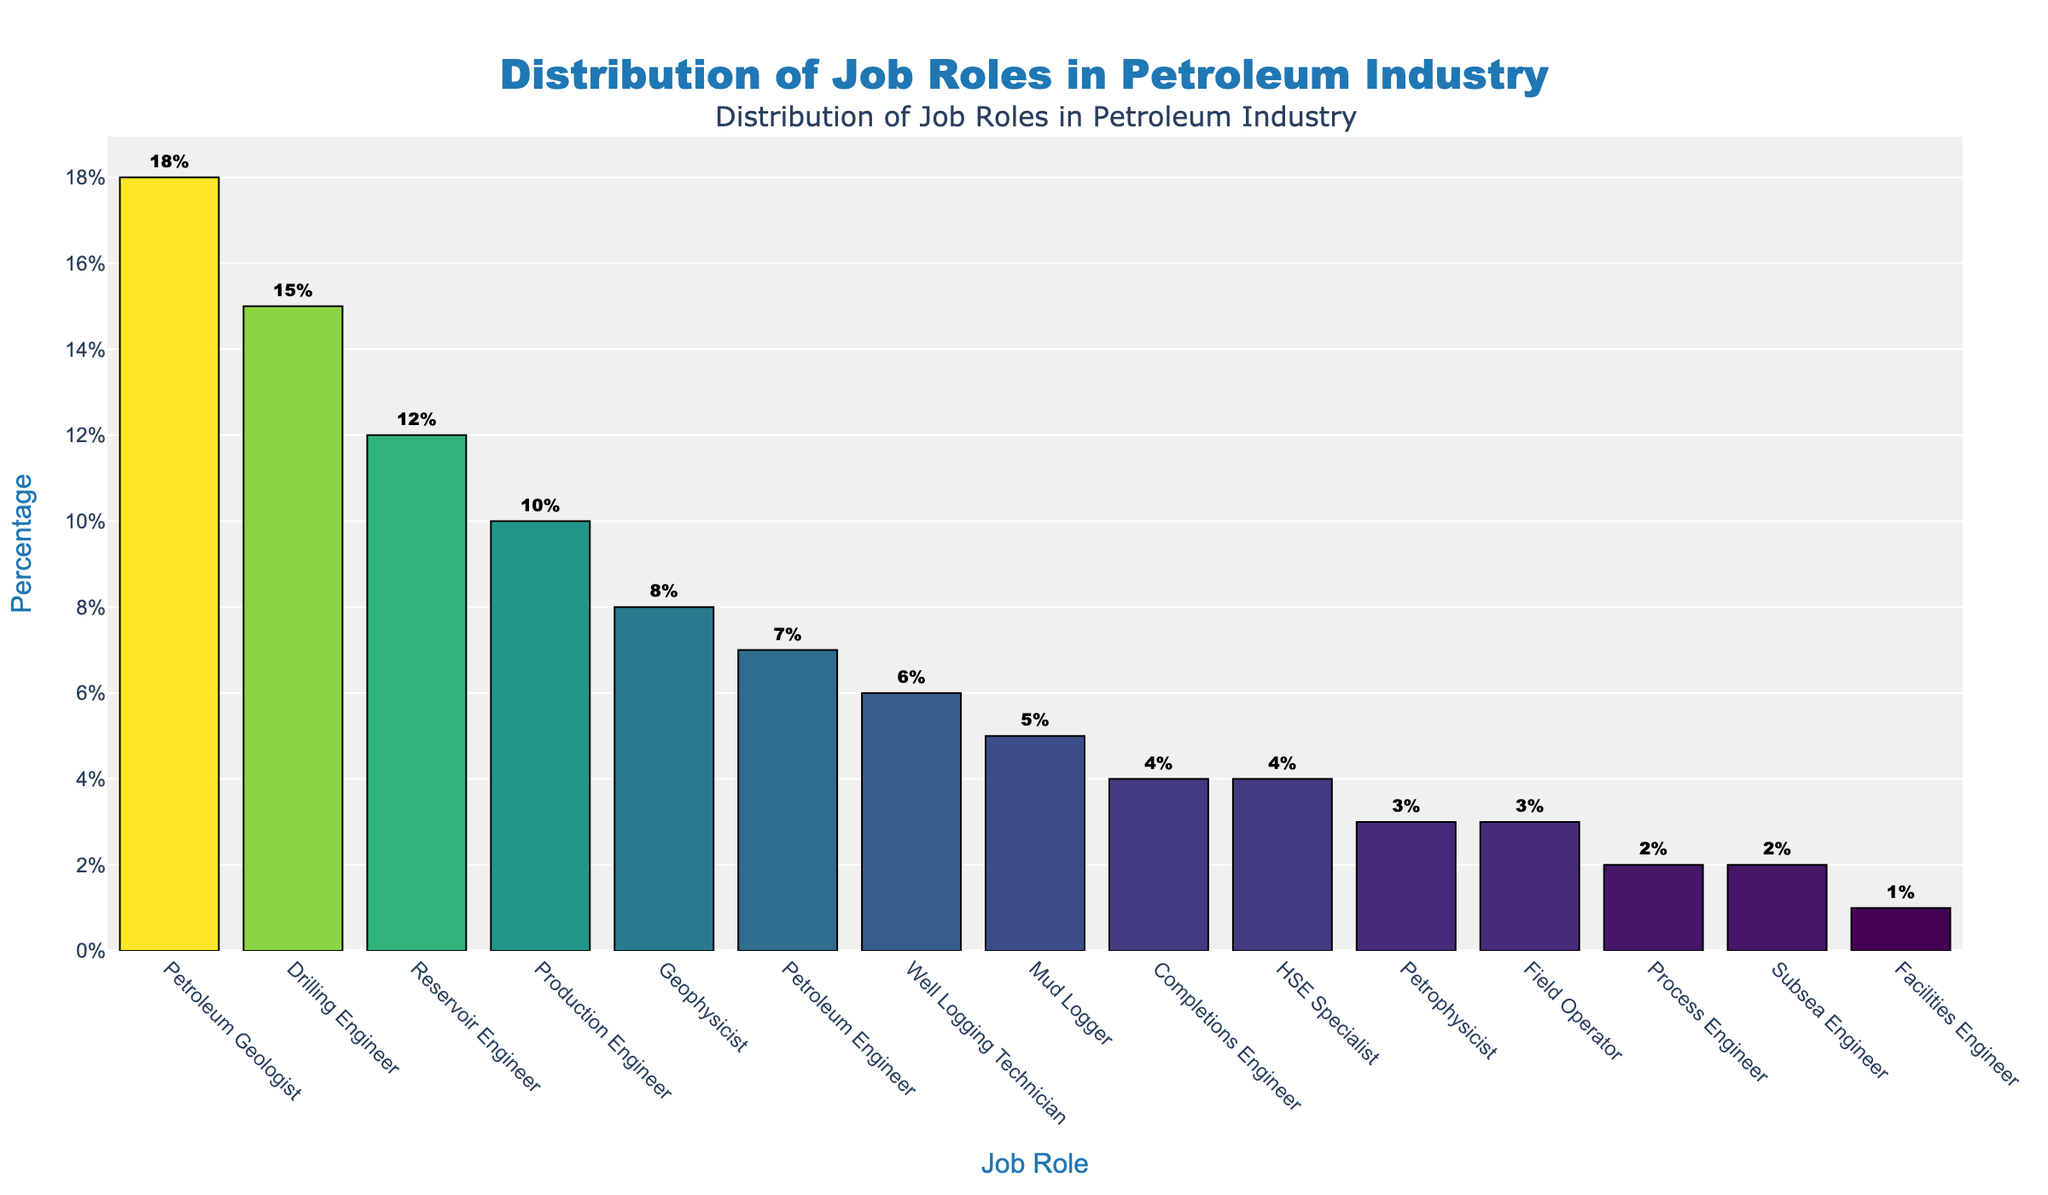Which job role has the highest percentage? The job role with the highest percentage is at the top of the sorted bar chart. By looking at the tallest bar, we can see it is 'Petroleum Geologist'.
Answer: Petroleum Geologist Which job role has the lowest percentage? The job role with the lowest percentage is at the bottom of the sorted bar chart. By looking at the shortest bar, we can see it is 'Facilities Engineer'.
Answer: Facilities Engineer What is the combined percentage for 'Drilling Engineer' and 'Reservoir Engineer'? Add the percentages of 'Drilling Engineer' and 'Reservoir Engineer' by looking at their respective bars in the bar chart. 'Drilling Engineer' is 15% and 'Reservoir Engineer' is 12%. Adding them together gives 15% + 12% = 27%.
Answer: 27% Is the percentage of 'Production Engineer' greater than that of 'Geophysicist'? Compare the heights of the bars for 'Production Engineer' and 'Geophysicist'. 'Production Engineer' has a percentage of 10% while 'Geophysicist' has 8%. Therefore, 10% is greater than 8%.
Answer: Yes What percentage of the total job roles does the 'Field Operator' and 'HSE Specialist' together constitute? First, find the percentages for 'Field Operator' and 'HSE Specialist', which are 3% and 4% respectively. Then, sum them up to find the total percentage: 3% + 4% = 7%.
Answer: 7% By how much does the percentage of 'Petroleum Engineer' exceed that of 'Mud Logger'? Subtract the percentage of 'Mud Logger' from that of 'Petroleum Engineer'. 'Petroleum Engineer' has 7% and 'Mud Logger' has 5%. So, 7% - 5% = 2%.
Answer: 2% What is the average percentage of the top three job roles? Identify the top three job roles by percentage which are 'Petroleum Geologist' (18%), 'Drilling Engineer' (15%), and 'Reservoir Engineer' (12%). Then, calculate the average: (18% + 15% + 12%) / 3 = 15%.
Answer: 15% Do 'Subsea Engineer' and 'Process Engineer' together have a higher percentage than 'Petroleum Geologist'? Compare the combined percentage of 'Subsea Engineer' (2%) and 'Process Engineer' (2%) to 'Petroleum Geologist' (18%). Their combined percentage is 2% + 2% = 4%, which is less than 18%.
Answer: No Which job role and its corresponding percentage are located exactly in the middle when sorted by percentage? The middle value in a sorted list means finding the median, which is the 8th value in a list of 15 values. The 8th value in this sorted list is 'Mud Logger' with 5%.
Answer: Mud Logger with 5% What is the total percentage of all job roles listed? Sum all the percentages of the job roles listed. The sum is: 18% + 15% + 12% + 10% + 8% + 7% + 6% + 5% + 4% + 4% + 3% + 3% + 2% + 2% + 1% = 100%.
Answer: 100% 